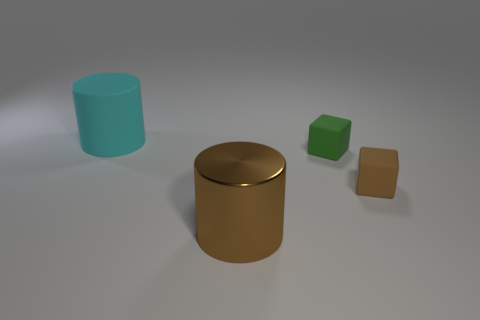Is the shape of the big shiny thing the same as the big cyan thing?
Offer a terse response. Yes. Is there another tiny object that has the same shape as the green object?
Your answer should be very brief. Yes. There is a large matte object that is behind the cylinder in front of the brown cube; what is its shape?
Provide a succinct answer. Cylinder. There is a large cylinder in front of the large matte object; what is its color?
Ensure brevity in your answer.  Brown. There is a brown block that is made of the same material as the cyan cylinder; what size is it?
Ensure brevity in your answer.  Small. What size is the other cyan object that is the same shape as the metallic thing?
Keep it short and to the point. Large. Is there a metal cylinder?
Make the answer very short. Yes. How many things are cylinders that are to the left of the metallic cylinder or small green things?
Provide a short and direct response. 2. There is a thing that is the same size as the brown block; what is it made of?
Keep it short and to the point. Rubber. There is a tiny matte cube that is behind the object right of the small green rubber thing; what is its color?
Make the answer very short. Green. 